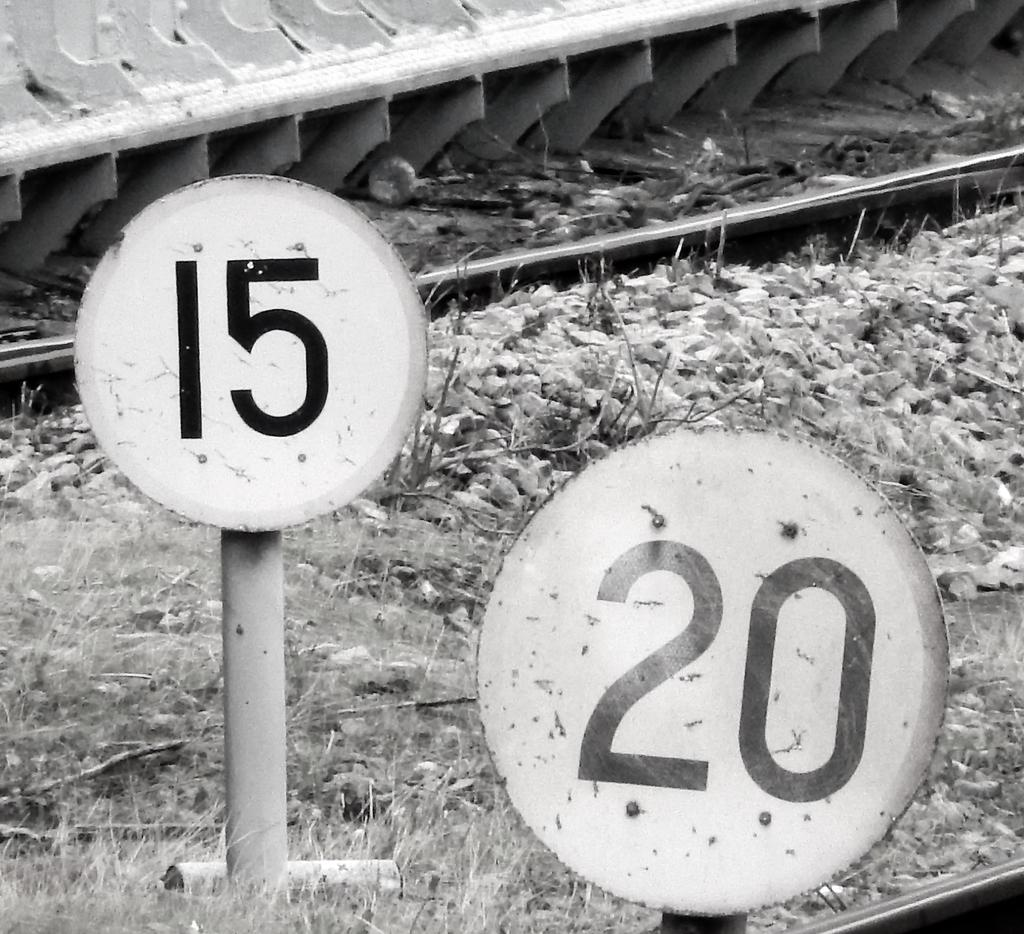<image>
Describe the image concisely. Two signs are in a grassy area that say 15 and 20. 